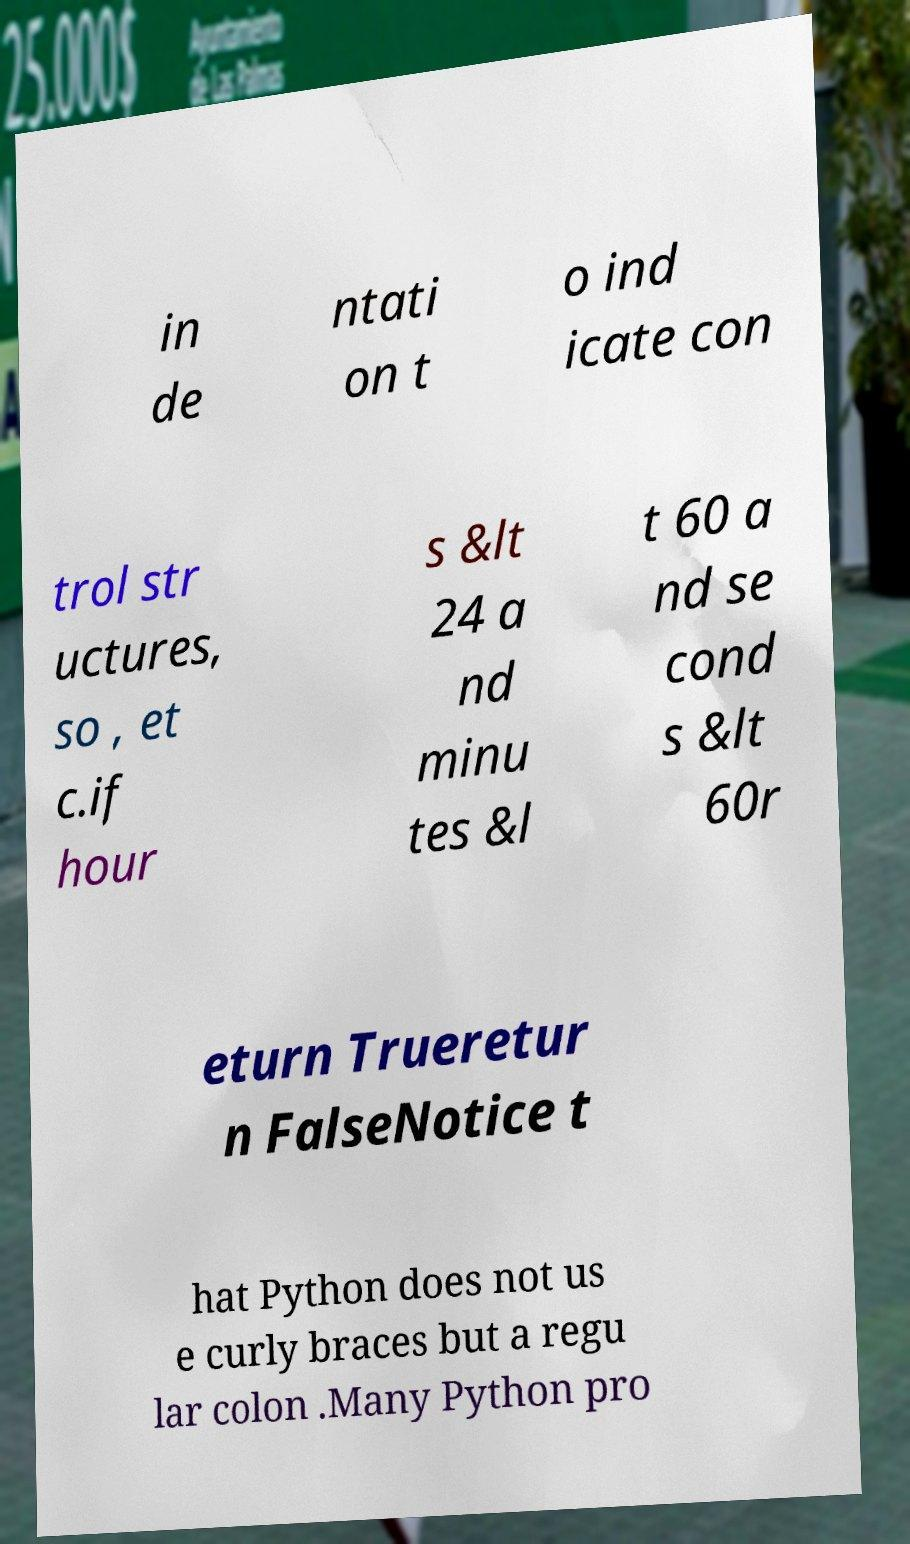Please read and relay the text visible in this image. What does it say? in de ntati on t o ind icate con trol str uctures, so , et c.if hour s &lt 24 a nd minu tes &l t 60 a nd se cond s &lt 60r eturn Trueretur n FalseNotice t hat Python does not us e curly braces but a regu lar colon .Many Python pro 